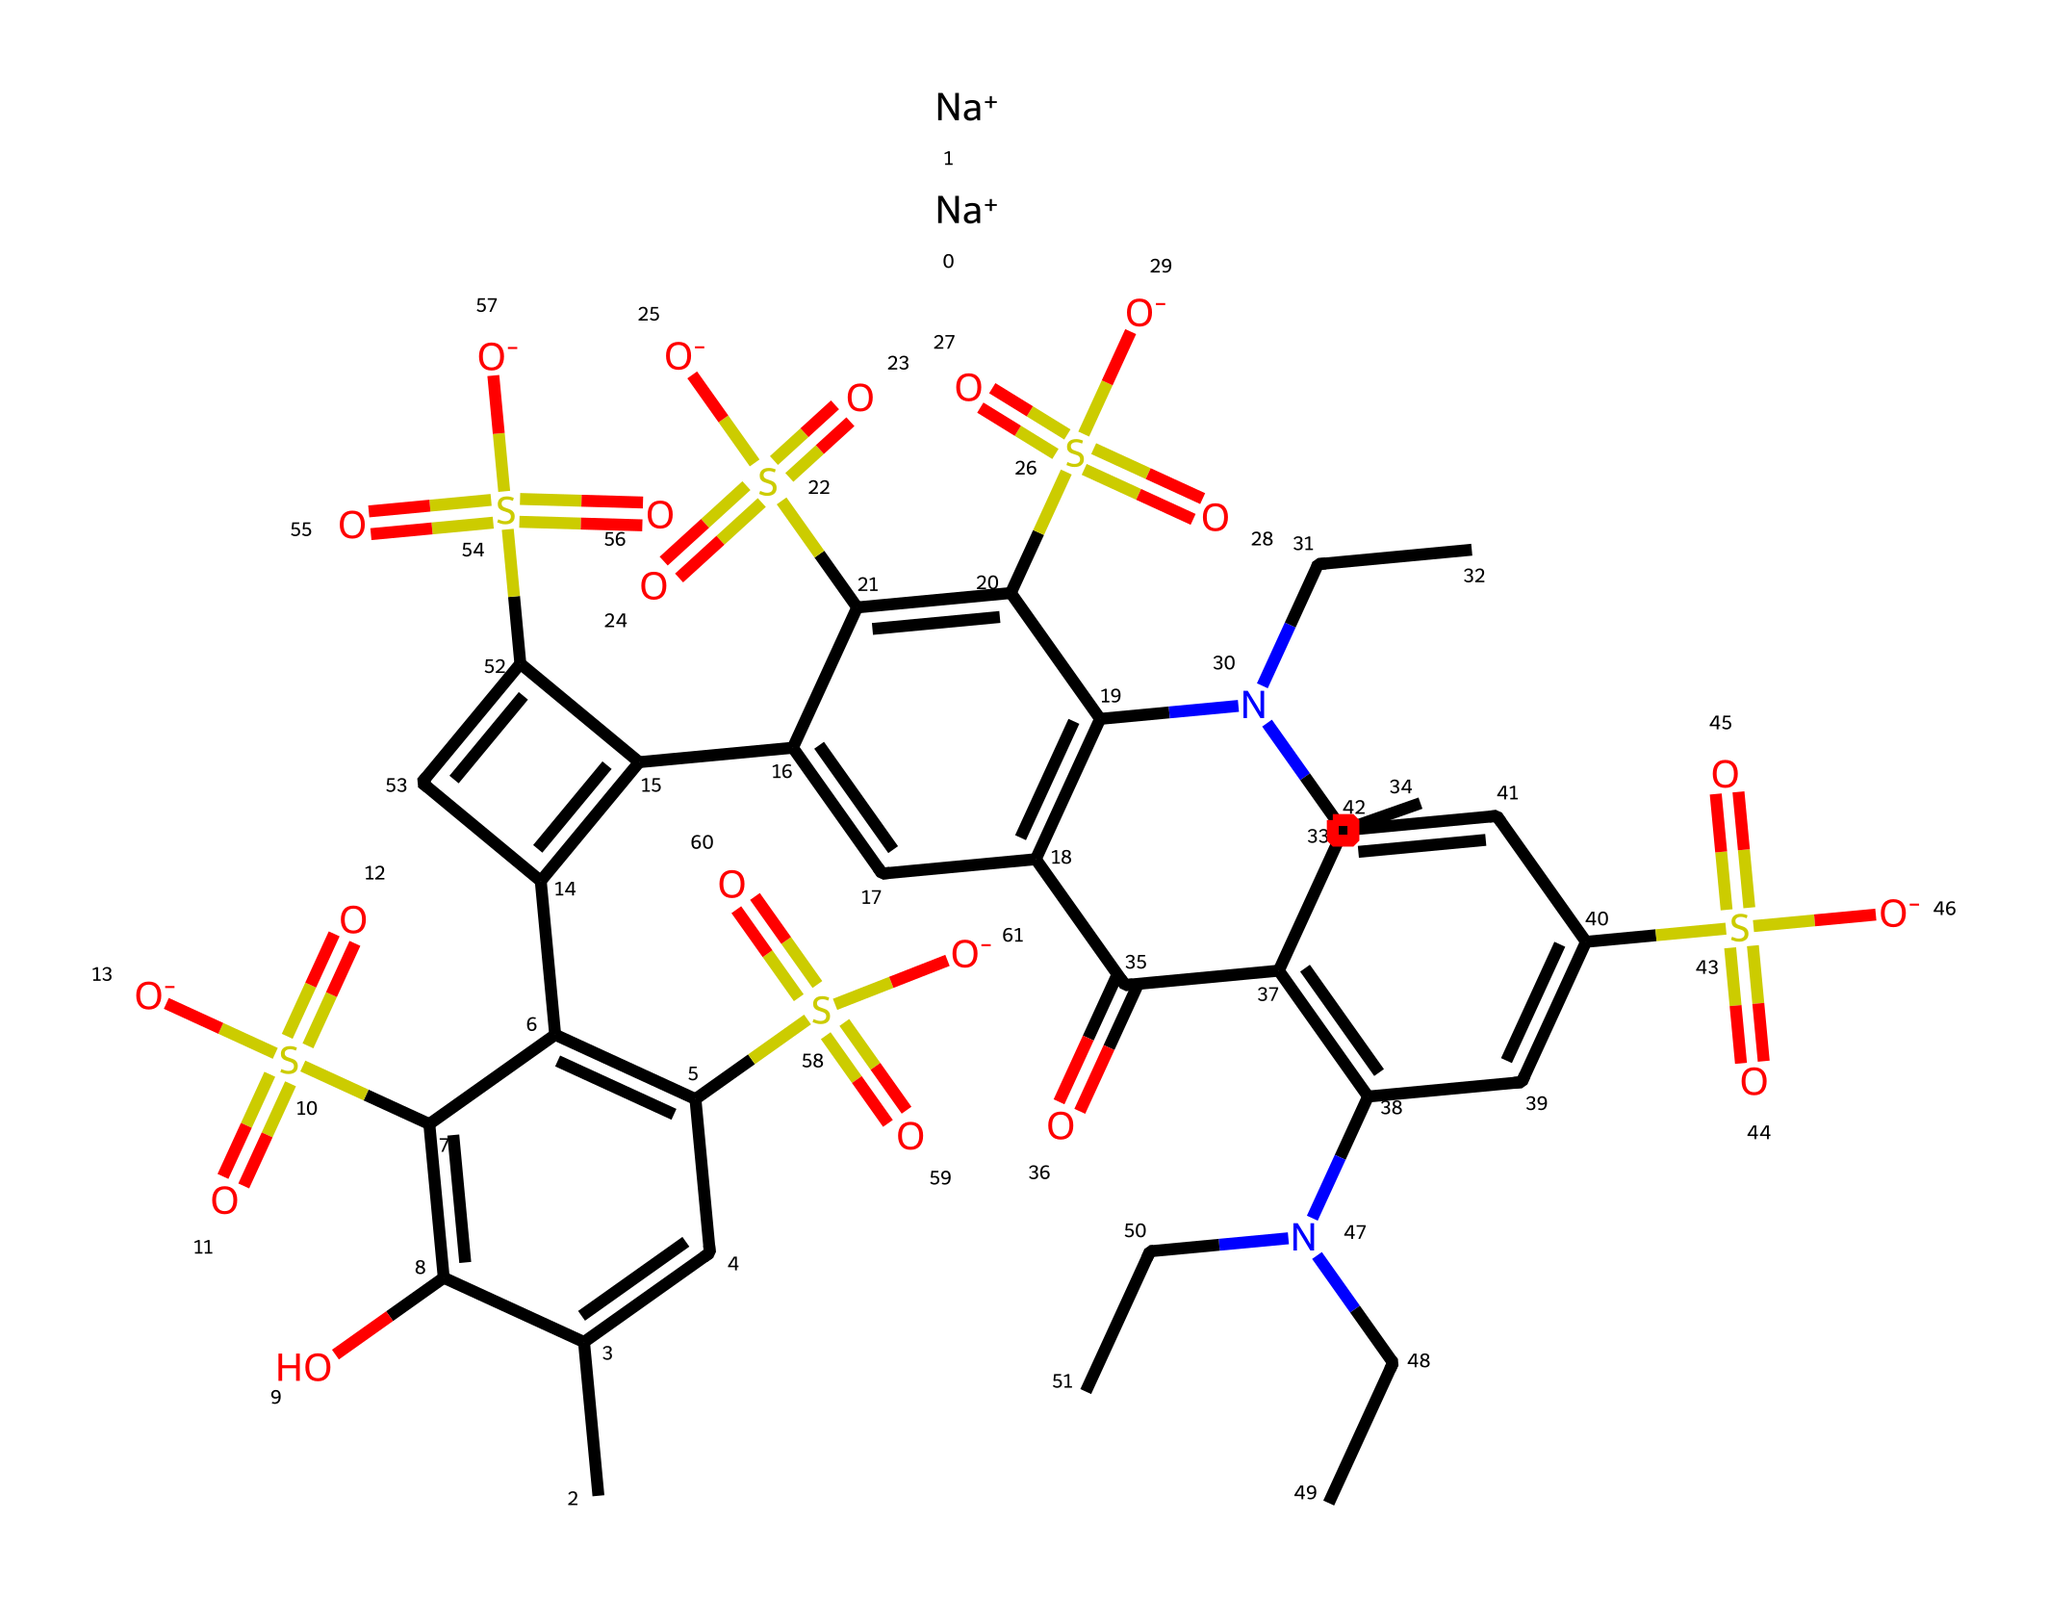what is the total number of nitrogen atoms in this chemical? By inspecting the SMILES representation, we can identify the presence of nitrogen by looking for the 'N' character. There are three instances of 'N' in the representation.
Answer: three how many sulfur atoms are present in the structure? The presence of sulfur is indicated by the 'S' character in the SMILES. By counting the occurrences of 'S', we find there are six instances.
Answer: six what type of dye is represented in this structure? The presence of multiple sulfonic acid groups (-SO3) indicates this is a type of azo dye, commonly known for bright colors in cleaning products.
Answer: azo dye how many hydroxyl groups are present in the molecule? Looking for 'O' followed by a hydrogen in the SMILES, we can identify hydroxyl (alcohol) groups. There are two 'OH' groups identified.
Answer: two what is the molecular feature that indicates this chemical can act as a cleaning agent? The presence of sulfonate groups, which increase solubility and help in removing dirt and stains, indicates its role as a cleaning agent.
Answer: sulfonate groups how many rings are in the chemical structure? By examining the 'C' characters connected in a cyclic format and using the '=' to determine connections, we can identify four distinct aromatic rings.
Answer: four 